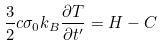<formula> <loc_0><loc_0><loc_500><loc_500>\frac { 3 } { 2 } c \sigma _ { 0 } k _ { B } \frac { \partial T } { \partial t ^ { \prime } } = H - C</formula> 